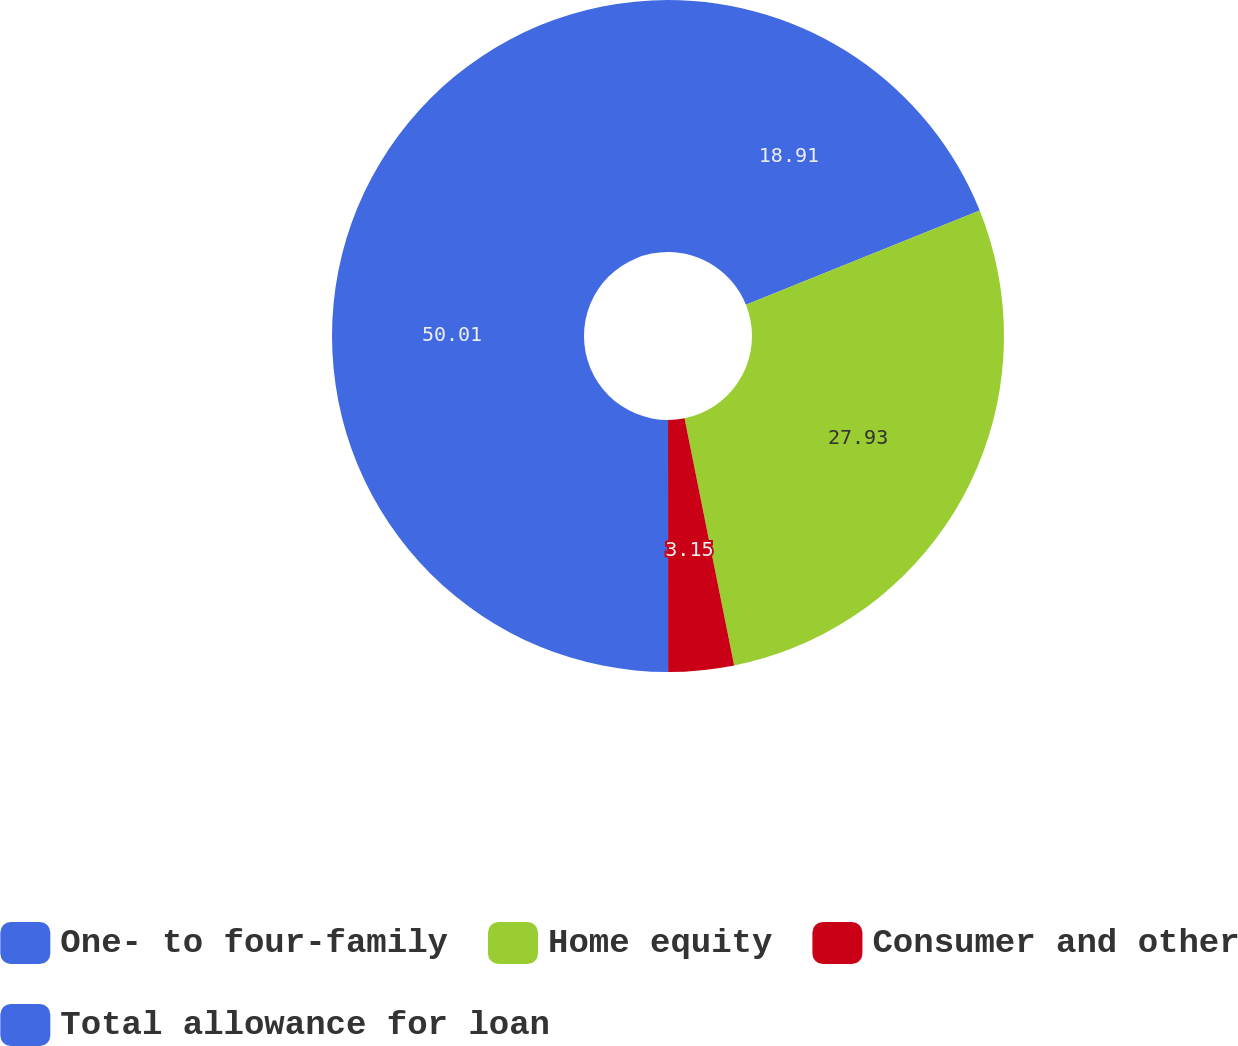Convert chart. <chart><loc_0><loc_0><loc_500><loc_500><pie_chart><fcel>One- to four-family<fcel>Home equity<fcel>Consumer and other<fcel>Total allowance for loan<nl><fcel>18.91%<fcel>27.93%<fcel>3.15%<fcel>50.0%<nl></chart> 